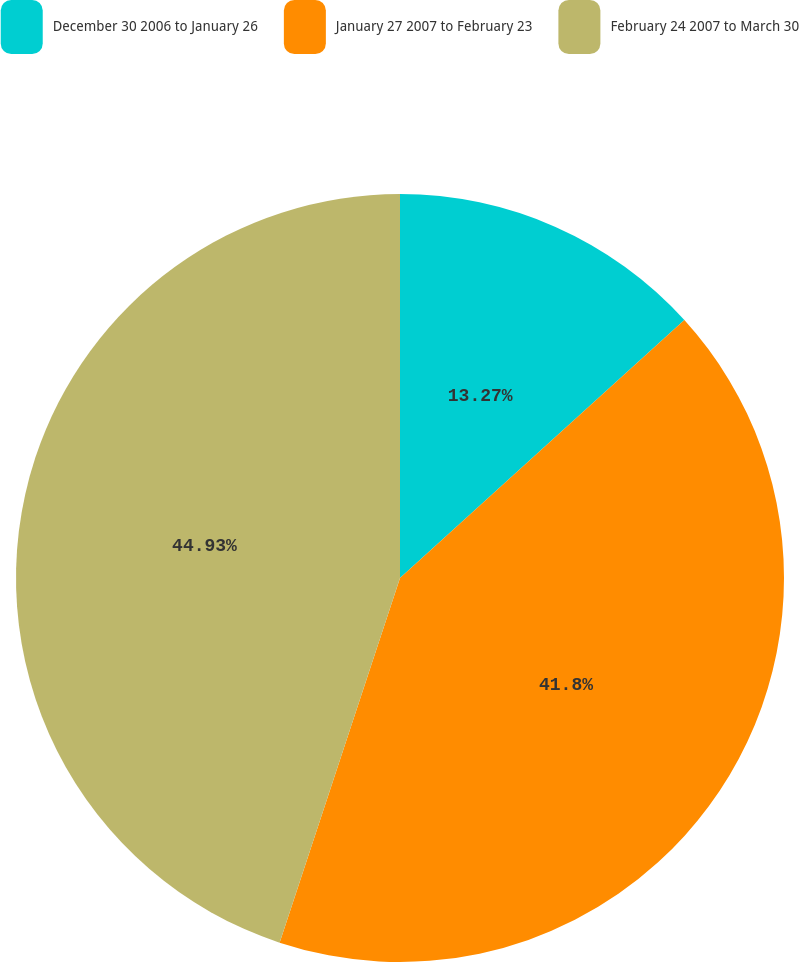Convert chart. <chart><loc_0><loc_0><loc_500><loc_500><pie_chart><fcel>December 30 2006 to January 26<fcel>January 27 2007 to February 23<fcel>February 24 2007 to March 30<nl><fcel>13.27%<fcel>41.8%<fcel>44.92%<nl></chart> 